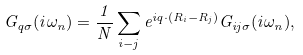Convert formula to latex. <formula><loc_0><loc_0><loc_500><loc_500>G _ { q \sigma } ( i \omega _ { n } ) = \frac { 1 } { N } \sum _ { i - j } e ^ { i q \cdot ( { R } _ { i } - { R } _ { j } ) } G _ { i j \sigma } ( i \omega _ { n } ) ,</formula> 